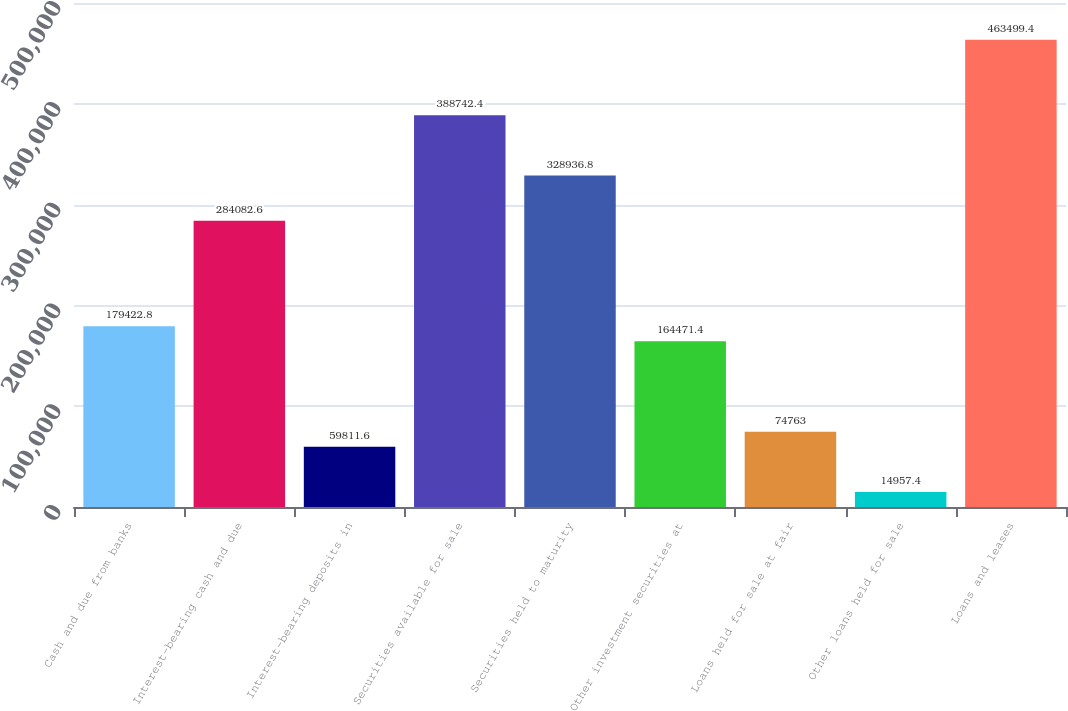<chart> <loc_0><loc_0><loc_500><loc_500><bar_chart><fcel>Cash and due from banks<fcel>Interest-bearing cash and due<fcel>Interest-bearing deposits in<fcel>Securities available for sale<fcel>Securities held to maturity<fcel>Other investment securities at<fcel>Loans held for sale at fair<fcel>Other loans held for sale<fcel>Loans and leases<nl><fcel>179423<fcel>284083<fcel>59811.6<fcel>388742<fcel>328937<fcel>164471<fcel>74763<fcel>14957.4<fcel>463499<nl></chart> 